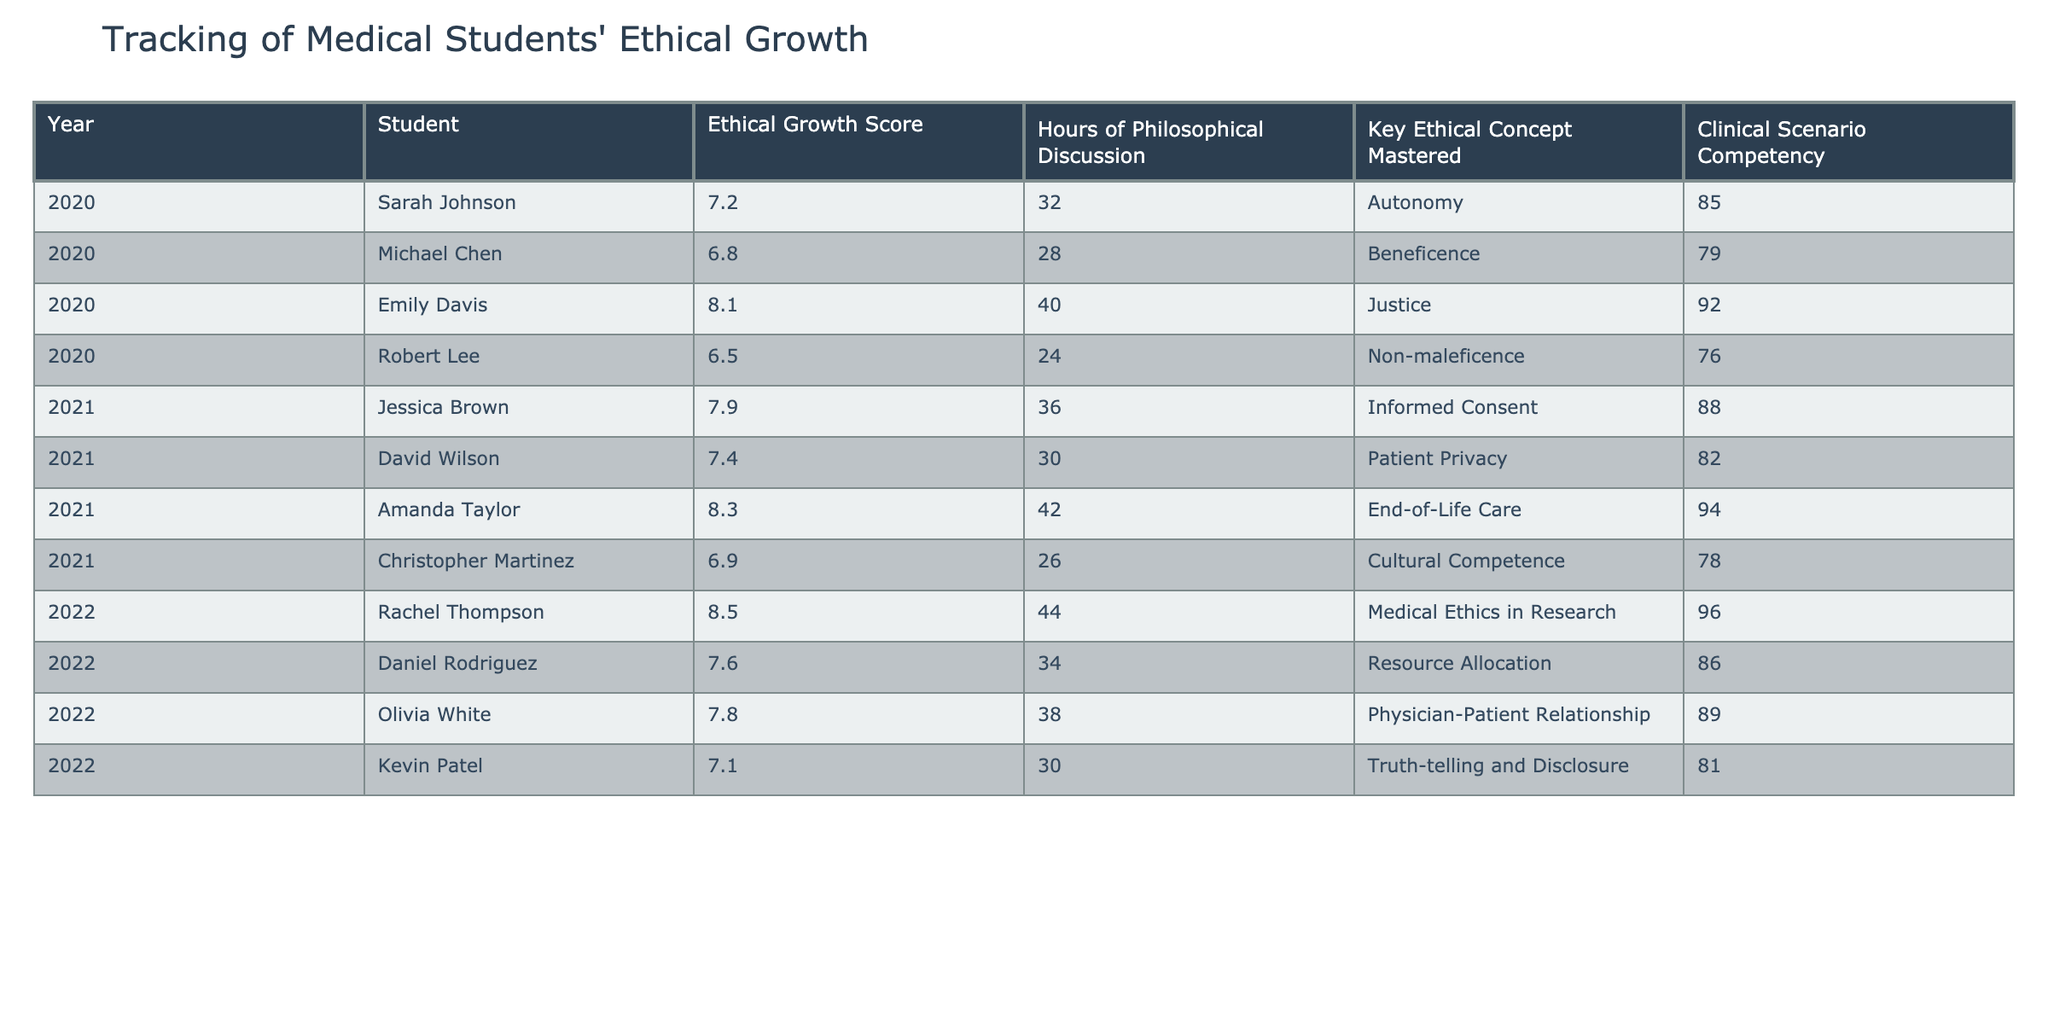What is the Ethical Growth Score of Emily Davis? The table shows that Emily Davis has an Ethical Growth Score listed in her row for the year 2020. The score is 8.1.
Answer: 8.1 Which student had the highest score in Clinical Scenario Competency? By examining the Clinical Scenario Competency values, we find that Rachel Thompson had the highest score at 96.
Answer: 96 What is the average Ethical Growth Score for the year 2021? The Ethical Growth Scores for 2021 are 7.9, 7.4, 8.3, and 6.9. Calculating the average, we sum these scores: (7.9 + 7.4 + 8.3 + 6.9) = 30.5, and divide by 4, giving us 30.5/4 = 7.625.
Answer: 7.625 Did Amanda Taylor master the key ethical concept of Autonomy? According to the table, the key ethical concept mastered by Amanda Taylor is End-of-Life Care, not Autonomy. Therefore, the answer is no.
Answer: No How many hours of philosophical discussion did Sarah Johnson have compared to Jessica Brown? Sarah Johnson had 32 hours, while Jessica Brown had 36 hours. The difference is calculated as 36 - 32 = 4 hours.
Answer: 4 hours Which student had the most hours of philosophical discussion in 2022, and what was their Ethical Growth Score? In 2022, Rachel Thompson had 44 hours of philosophical discussion and an Ethical Growth Score of 8.5.
Answer: Rachel Thompson, 8.5 If we consider the students who scored above 8.0 in Ethical Growth Score, how many of them are there? The students with scores above 8.0 are Emily Davis (8.1), Amanda Taylor (8.3), and Rachel Thompson (8.5), so there are three such students.
Answer: 3 What is the relationship between the number of hours of philosophical discussion and the Ethical Growth Score? To analyze this, one would compare the scores and hours. For example, Rachel Thompson has the highest hours (44) and the highest score (8.5). This suggests a positive relationship, but a full analysis would require more statistical data.
Answer: Positive relationship indicated Which student showed consistent improvement in both Ethical Growth Score and Clinical Scenario Competency from 2020 to 2022? Rachel Thompson, who scored 8.5 in 2022 after prior scores of 7.2 and 8.1 and whose Clinical Scenario Competency improved from 85 to 96, indicates consistent improvement.
Answer: Rachel Thompson Did any student score below 7.0 in Ethical Growth Score in 2022? The table indicates that all students in 2022 scored above 7.0. Thus, the answer is no.
Answer: No 